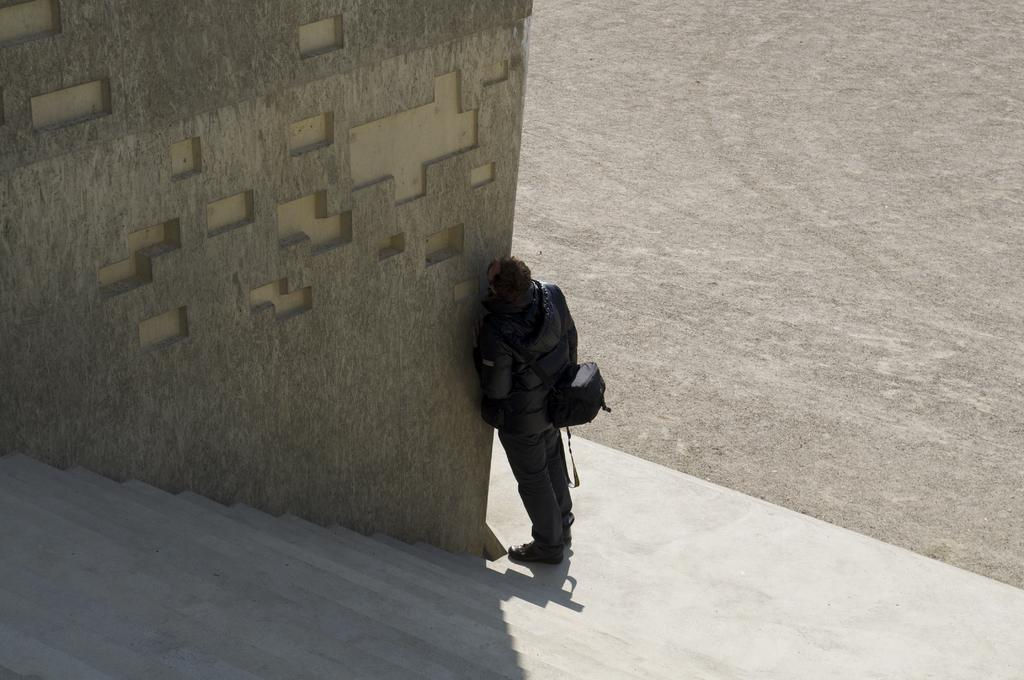What is the main subject of the image? There is a person in the image. What is the person wearing? The person is wearing a bag. Where is the person standing in relation to the wall? The person is standing beside the wall. What feature can be seen on the wall? There are stairs visible on the wall. What is on the other side of the wall? There is a ground on the other side of the wall. What type of toys can be seen scattered on the ground in the image? There are no toys present in the image. What kind of art is displayed on the wall in the image? There is no art displayed on the wall in the image; it only features stairs. 